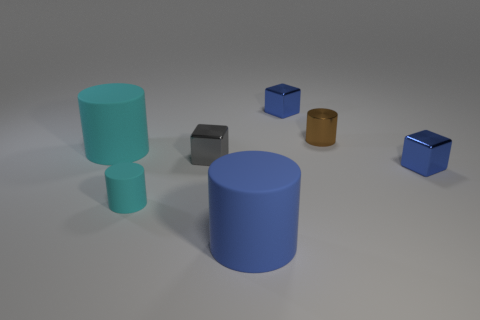There is a rubber cylinder that is in front of the small cyan matte cylinder; how big is it?
Provide a succinct answer. Large. What number of tiny objects are both right of the small brown thing and to the left of the gray shiny cube?
Keep it short and to the point. 0. How many other objects are the same size as the brown shiny object?
Your answer should be compact. 4. There is a object that is on the right side of the large cyan object and on the left side of the small gray metal block; what is its material?
Your answer should be compact. Rubber. Does the tiny matte thing have the same color as the large thing on the left side of the small cyan rubber object?
Keep it short and to the point. Yes. There is a metallic object that is the same shape as the big cyan rubber thing; what is its size?
Ensure brevity in your answer.  Small. The blue object that is both behind the big blue rubber cylinder and in front of the shiny cylinder has what shape?
Your answer should be very brief. Cube. Do the brown metallic cylinder and the gray shiny thing that is on the right side of the small cyan matte object have the same size?
Offer a very short reply. Yes. There is another large rubber object that is the same shape as the large blue thing; what color is it?
Make the answer very short. Cyan. There is a metal block that is on the right side of the tiny brown cylinder; is it the same size as the blue metal cube that is left of the tiny brown cylinder?
Your response must be concise. Yes. 